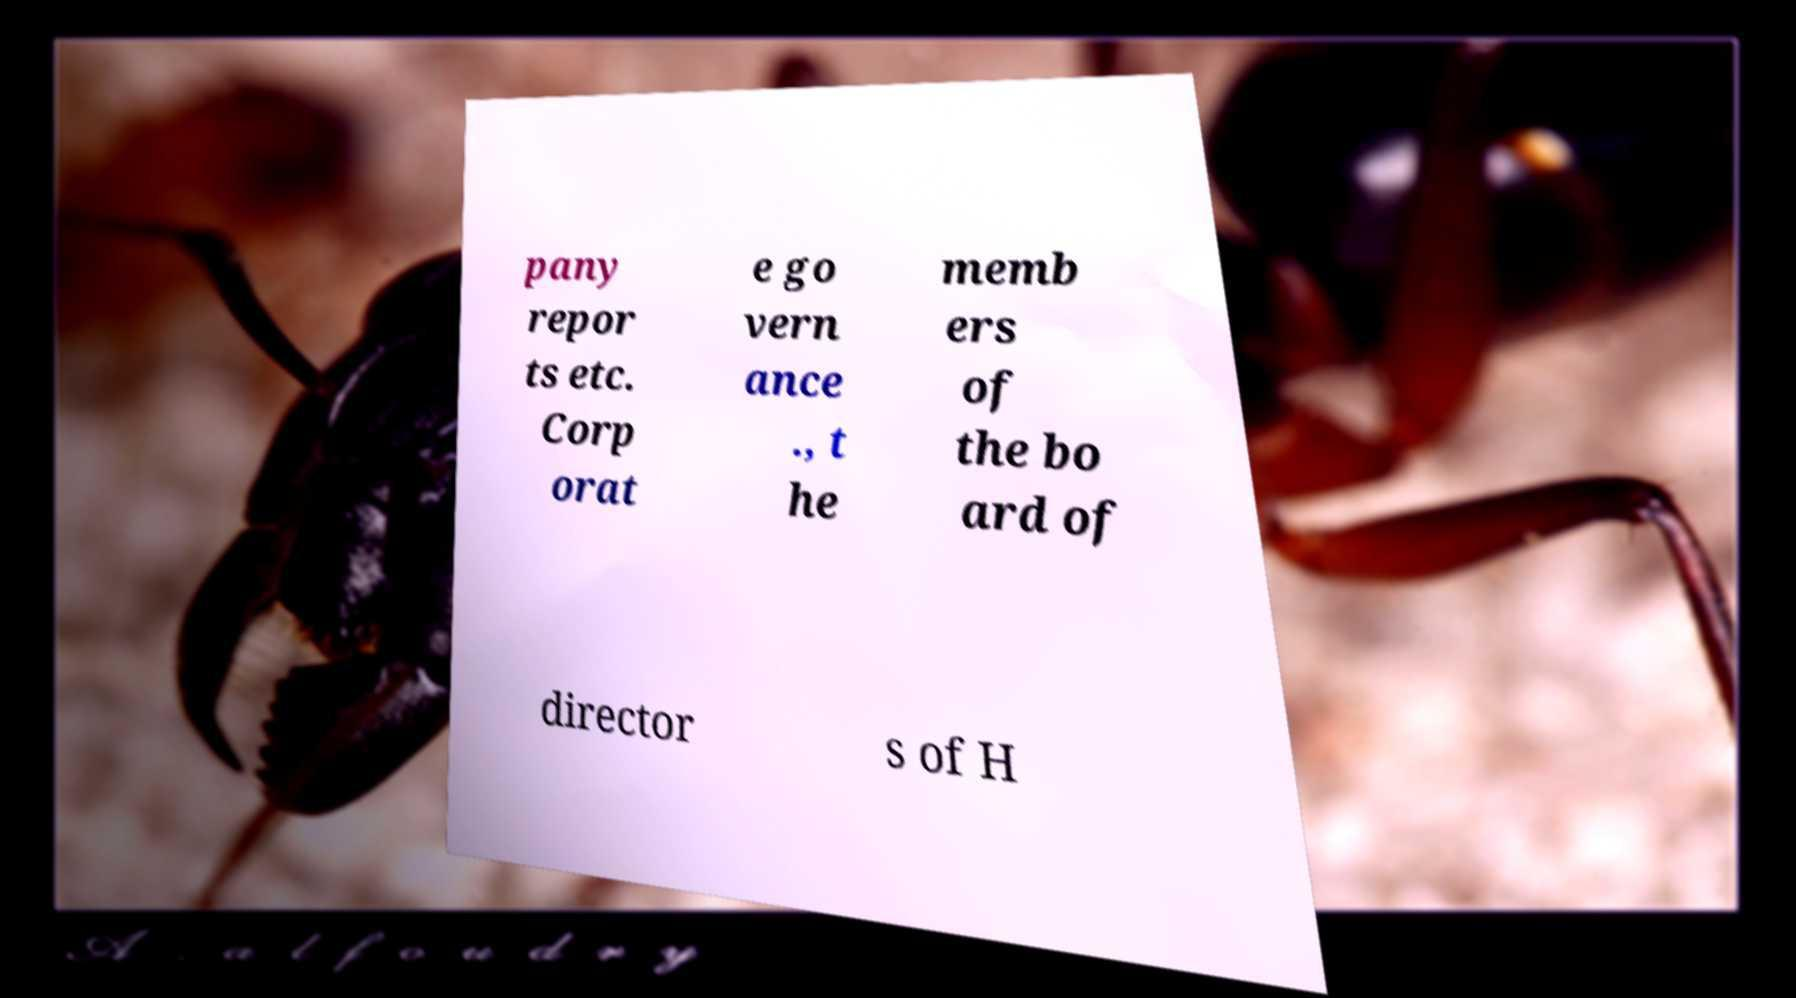Can you accurately transcribe the text from the provided image for me? pany repor ts etc. Corp orat e go vern ance ., t he memb ers of the bo ard of director s of H 